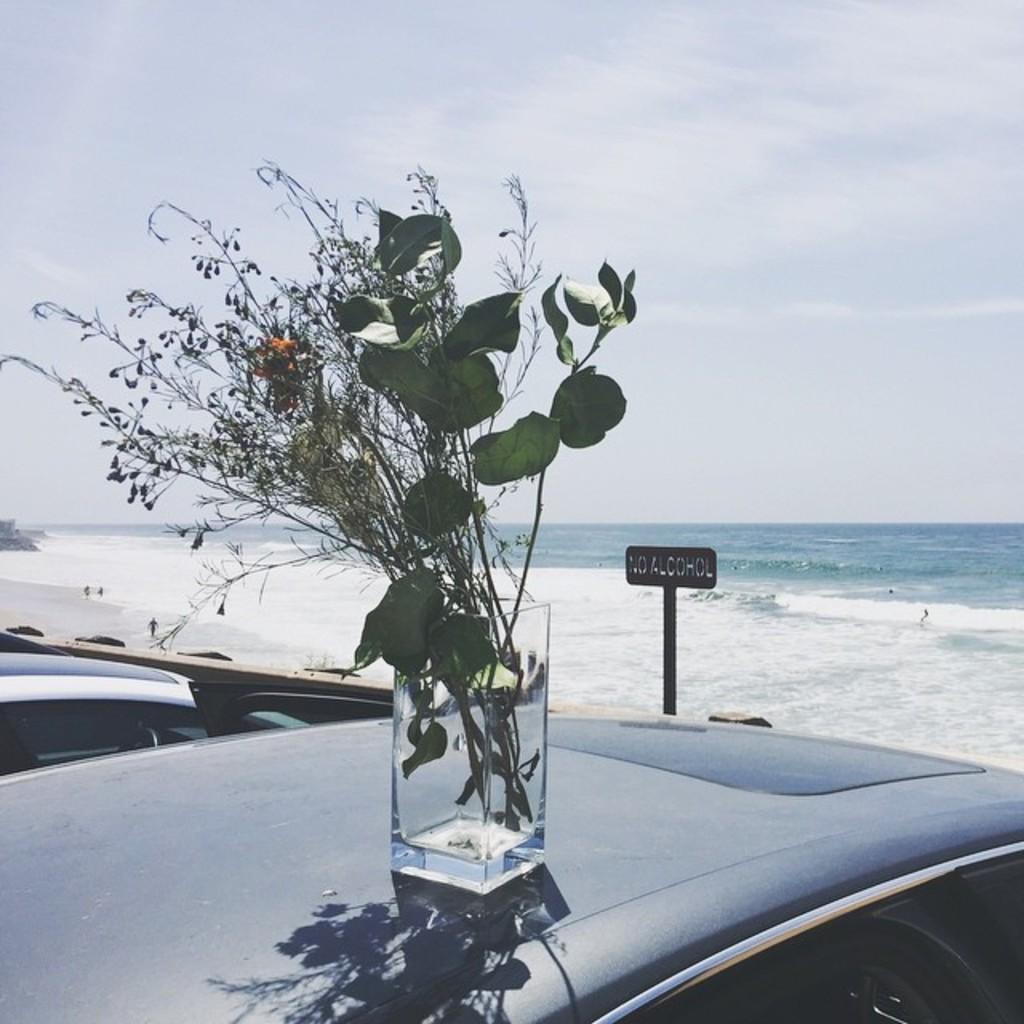Please provide a concise description of this image. In this image, in the middle, we can see a glass with some plant in it and the glass is placed on the car. In the background, we can see a board, a group of people drowning in the water. At the top, we can see a sky, at the bottom, we can see water in an ocean and a sand. 